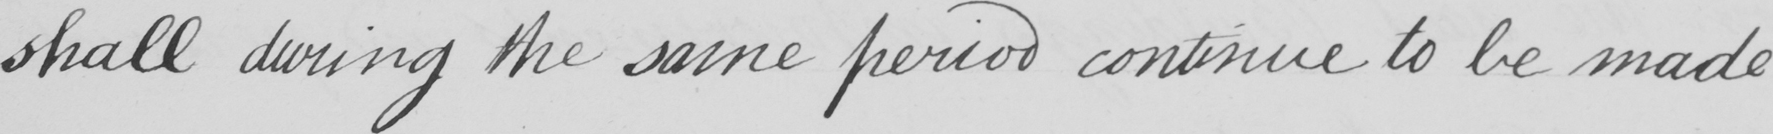Please transcribe the handwritten text in this image. shall during the same period continue to be made 